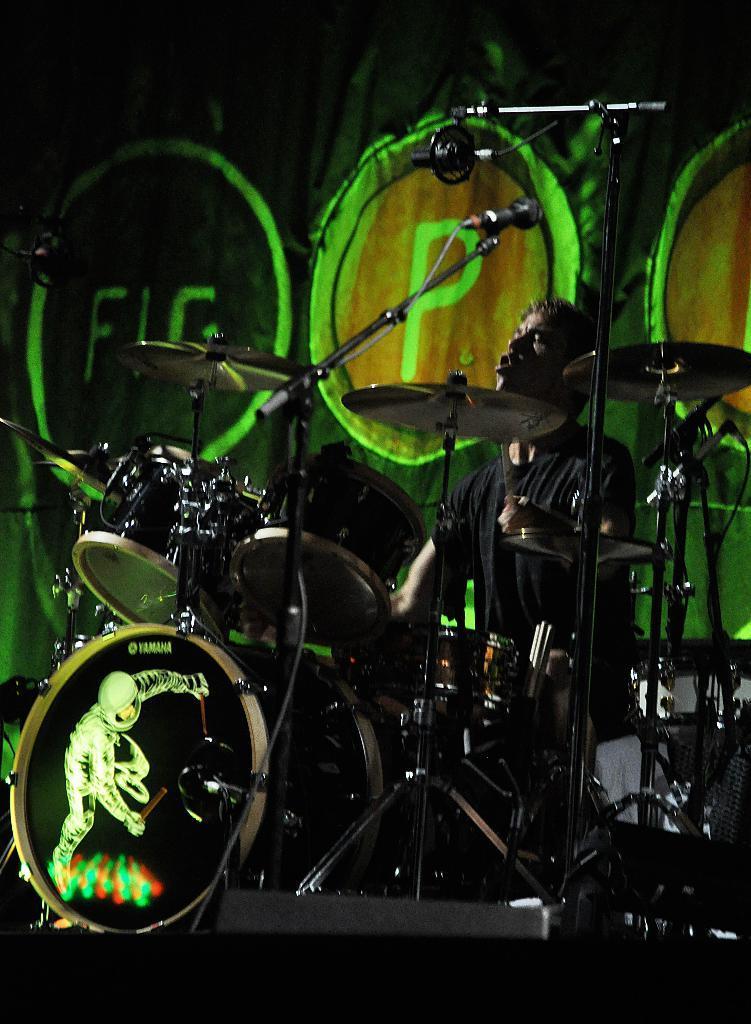In one or two sentences, can you explain what this image depicts? In this image there is a man sitting and playing drums. He is also singing. In front of him there are many drugs on the drums stands. There is a microphone to the microphone stand. In the background there is a wall. There is text on the wall. 